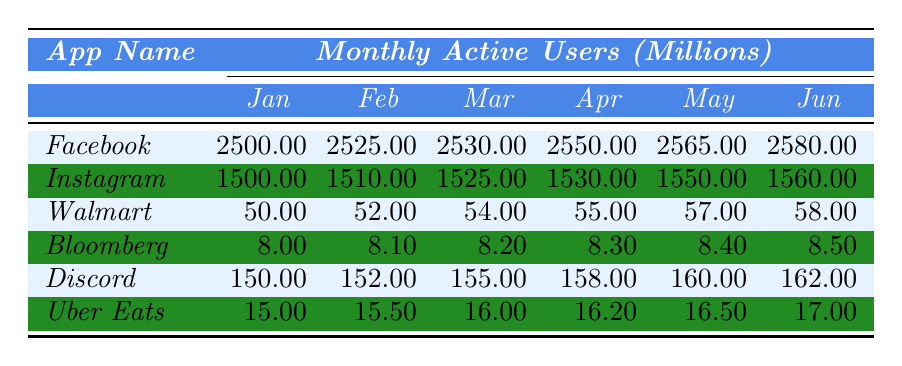What were the monthly active users of Facebook in March? According to the table, the value for Facebook in March is 2530 million users.
Answer: 2530 million What app had the least number of monthly active users in January? By examining the January column for all apps, Bloomberg had the lowest value of 8 million users.
Answer: Bloomberg How many monthly active users did Instagram gain from February to June? From February (1510 million) to June (1560 million), Instagram gained 50 million users (1560 - 1510 = 50).
Answer: 50 million What was the average number of monthly active users for Discord from January to June? To find the average, sum all values for Discord (150 + 152 + 155 + 158 + 160 + 162 = 937) and divide by the number of months (6). So, the average is 937 / 6 ≈ 156.17 million.
Answer: 156.17 million Did Walmart's monthly active users increase every month from January to June? Yes, by checking the values, Walmart's user count increased from January (50 million) to June (58 million) without any decreases.
Answer: Yes In which month did Uber Eats see the highest increase in monthly active users compared to the previous month? The largest increase occurred from May (16.50 million) to June (17 million), resulting in an increase of 0.50 million.
Answer: From May to June What was the total number of active users for all apps in January? The total for January is obtained by adding all monthly active users: 2500 + 1500 + 50 + 8 + 150 + 15 = 4223 million.
Answer: 4223 million Which app had a consistent increase in monthly active users every month throughout the entire period? Both Facebook and Instagram consistently increased their monthly users each month, showing no decrease.
Answer: Facebook and Instagram What is the difference in monthly active users between the highest and lowest app in June? In June, Facebook had the highest with 2580 million and Bloomberg had the lowest with 8.50 million, thus the difference is 2580 - 8.50 = 2571.50 million.
Answer: 2571.50 million Which app had a total of 16 million users in April? Looking through the data, Uber Eats had 16.20 million users in April, which is the closest to 16 million.
Answer: Uber Eats What percentage of monthly active users did Discord represent in relation to Facebook's users in January? Discord had 150 million and Facebook had 2500 million in January. The percentage is calculated as (150 / 2500) * 100 = 6%.
Answer: 6% 